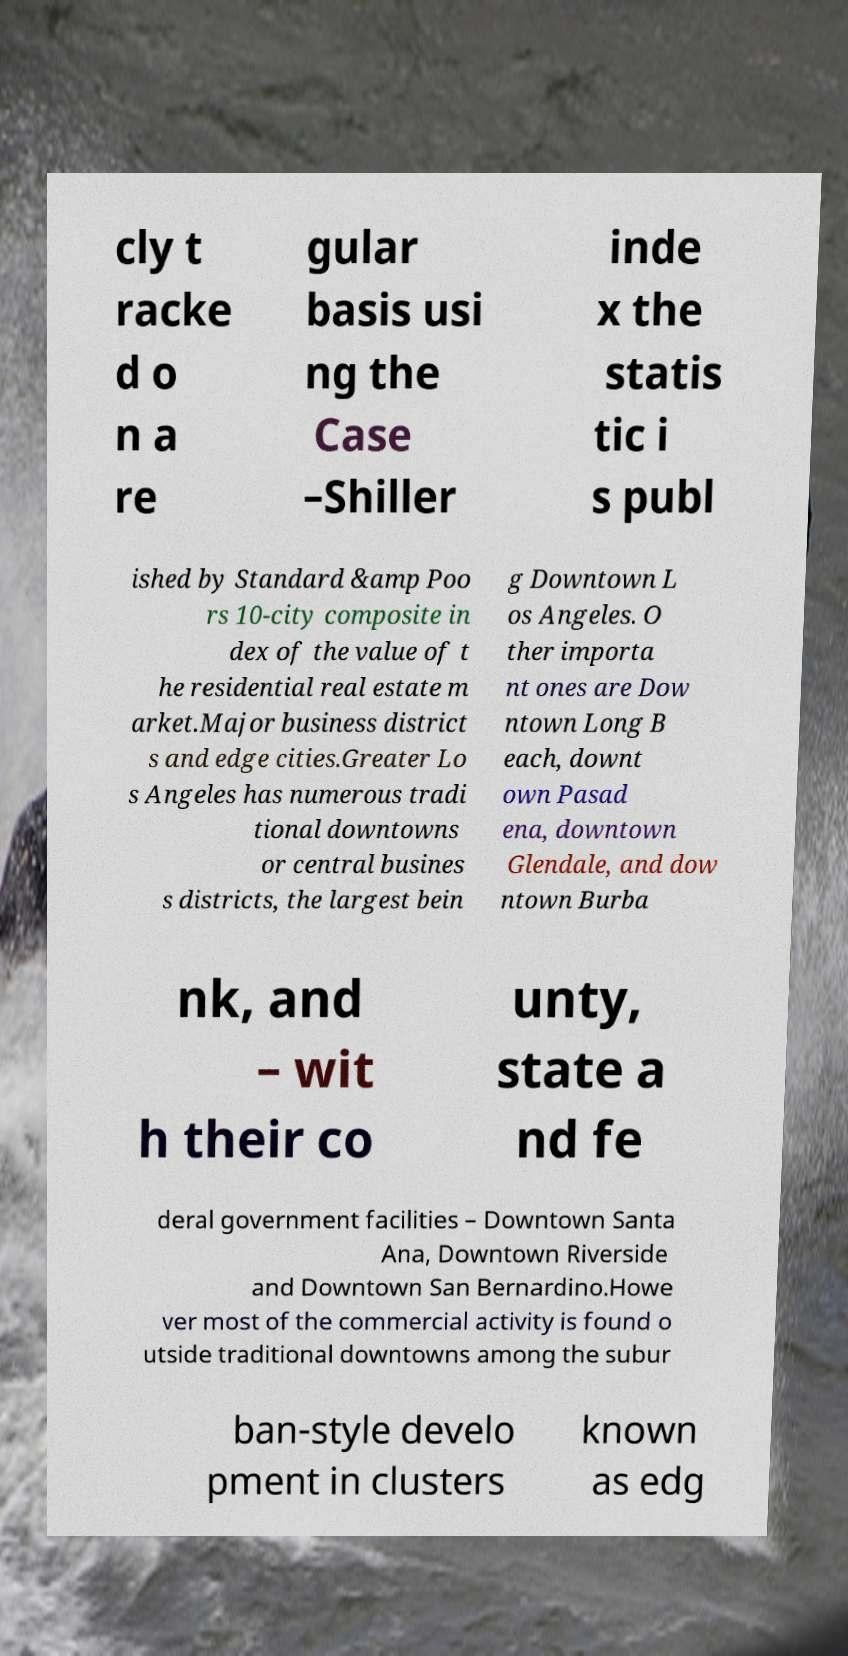Could you extract and type out the text from this image? cly t racke d o n a re gular basis usi ng the Case –Shiller inde x the statis tic i s publ ished by Standard &amp Poo rs 10-city composite in dex of the value of t he residential real estate m arket.Major business district s and edge cities.Greater Lo s Angeles has numerous tradi tional downtowns or central busines s districts, the largest bein g Downtown L os Angeles. O ther importa nt ones are Dow ntown Long B each, downt own Pasad ena, downtown Glendale, and dow ntown Burba nk, and – wit h their co unty, state a nd fe deral government facilities – Downtown Santa Ana, Downtown Riverside and Downtown San Bernardino.Howe ver most of the commercial activity is found o utside traditional downtowns among the subur ban-style develo pment in clusters known as edg 